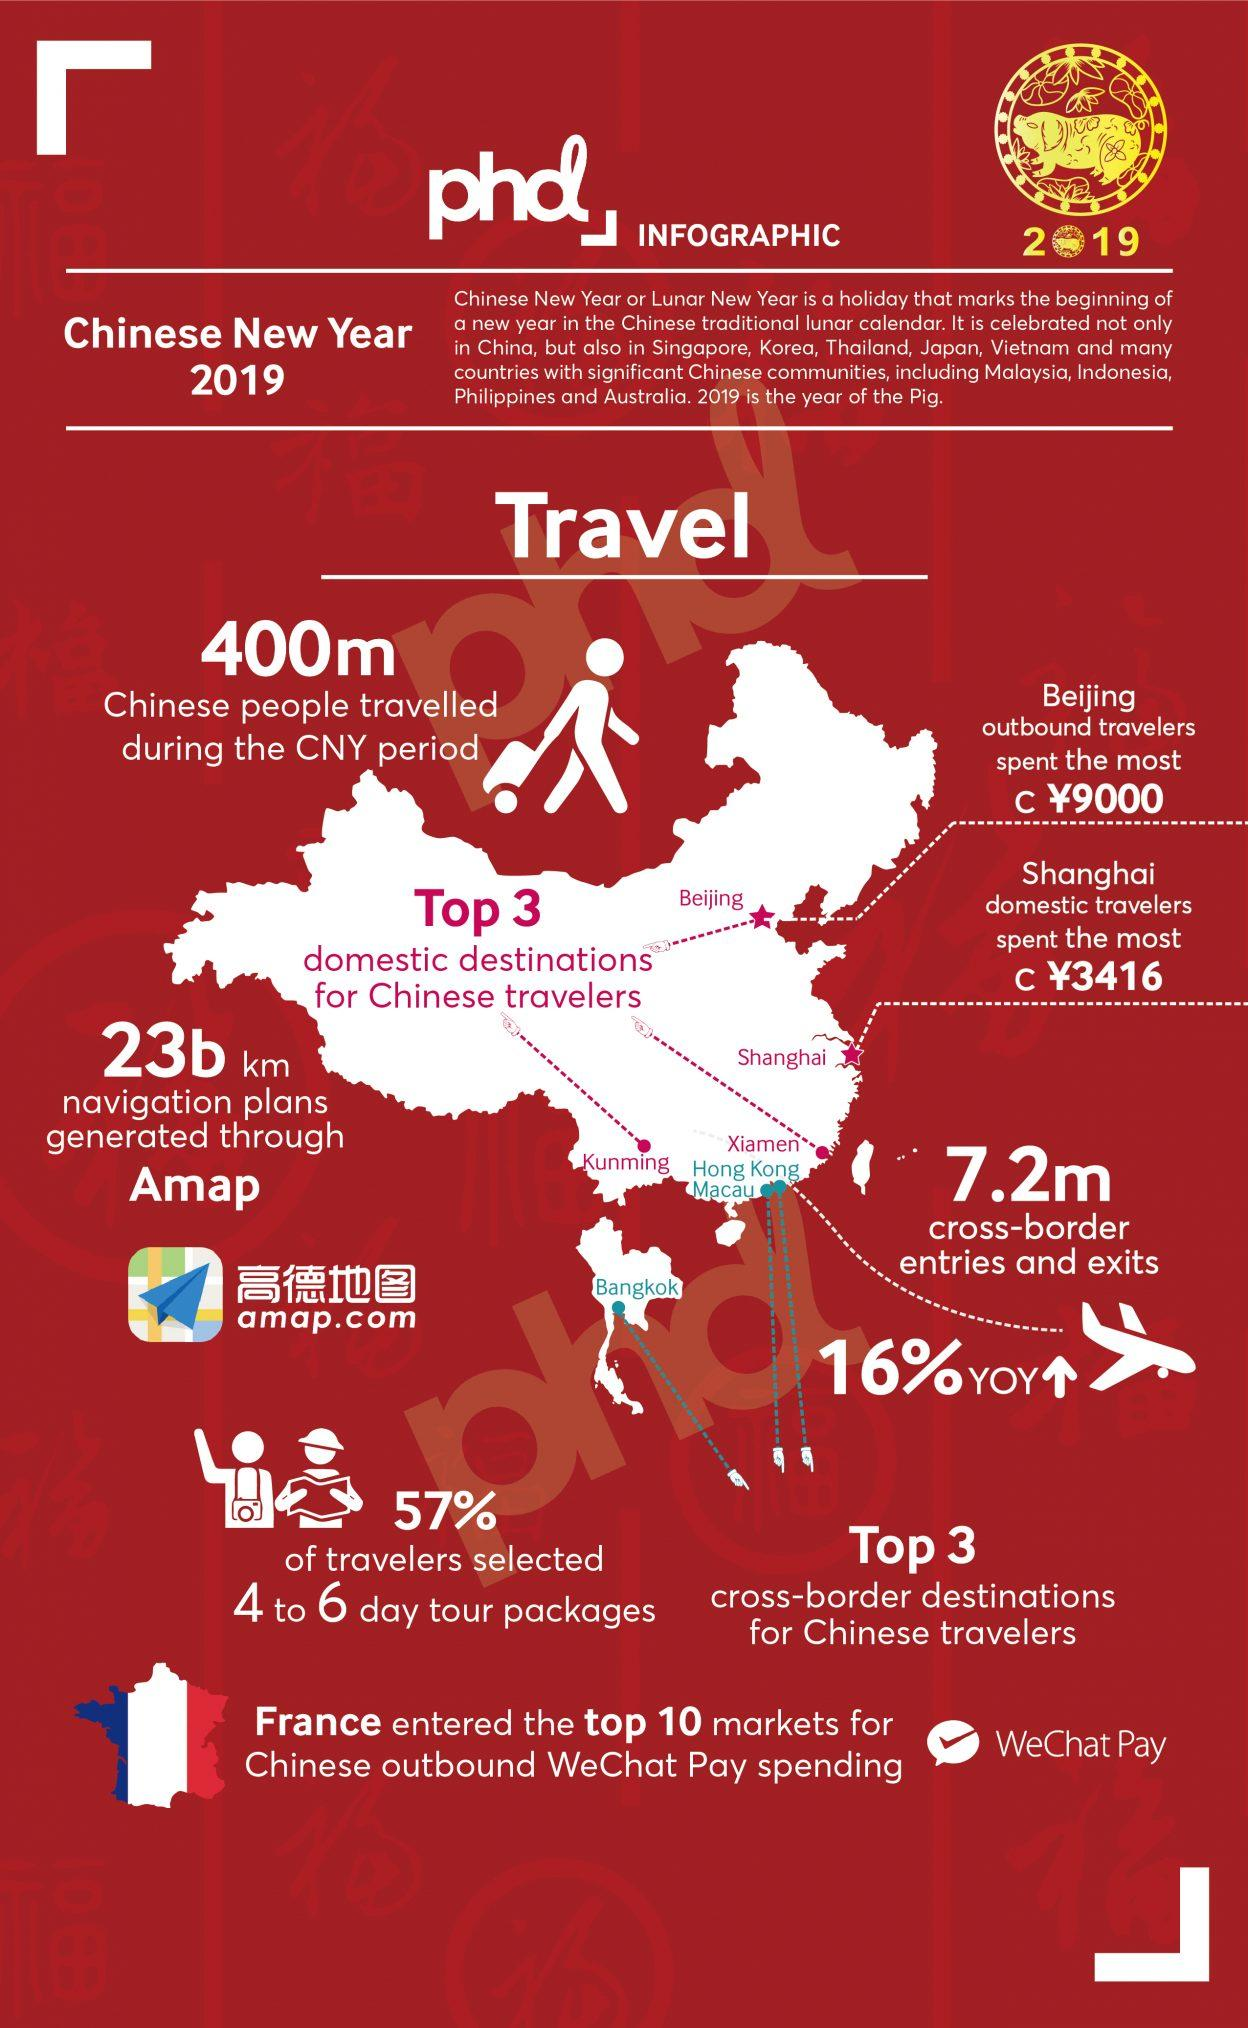Outline some significant characteristics in this image. There are four listed domestic destinations. The total amount spent by outbound travelers from Beijing and Shanghai is 12,416. There are a total of 3 cross-border destinations listed. The animal that can be seen on the yellow image is a pig. How many popular destinations are listed on the map? The number is 7. 